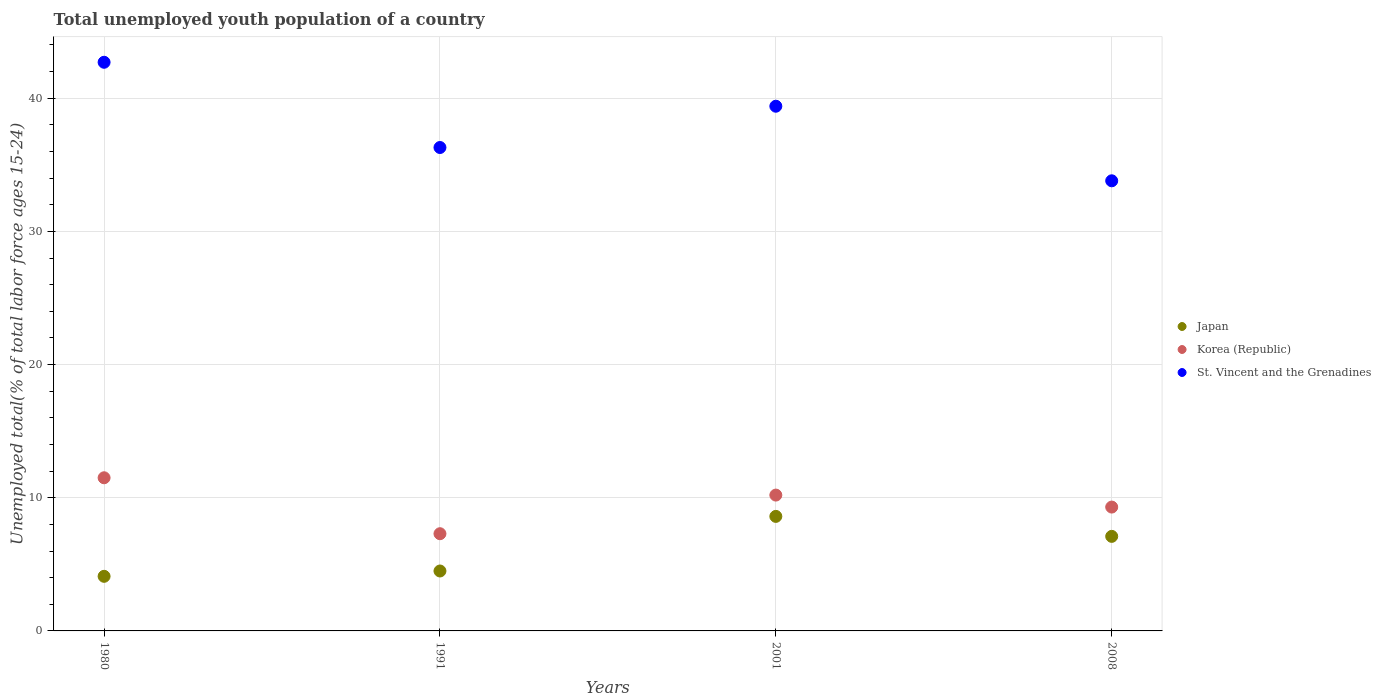Is the number of dotlines equal to the number of legend labels?
Provide a succinct answer. Yes. What is the percentage of total unemployed youth population of a country in Japan in 1980?
Make the answer very short. 4.1. Across all years, what is the maximum percentage of total unemployed youth population of a country in Japan?
Offer a very short reply. 8.6. Across all years, what is the minimum percentage of total unemployed youth population of a country in St. Vincent and the Grenadines?
Keep it short and to the point. 33.8. What is the total percentage of total unemployed youth population of a country in St. Vincent and the Grenadines in the graph?
Your answer should be very brief. 152.2. What is the difference between the percentage of total unemployed youth population of a country in Japan in 1980 and that in 2001?
Ensure brevity in your answer.  -4.5. What is the difference between the percentage of total unemployed youth population of a country in Korea (Republic) in 1991 and the percentage of total unemployed youth population of a country in Japan in 2008?
Make the answer very short. 0.2. What is the average percentage of total unemployed youth population of a country in Japan per year?
Make the answer very short. 6.08. In the year 2001, what is the difference between the percentage of total unemployed youth population of a country in Korea (Republic) and percentage of total unemployed youth population of a country in Japan?
Give a very brief answer. 1.6. In how many years, is the percentage of total unemployed youth population of a country in Japan greater than 20 %?
Your answer should be compact. 0. What is the ratio of the percentage of total unemployed youth population of a country in Korea (Republic) in 2001 to that in 2008?
Make the answer very short. 1.1. Is the percentage of total unemployed youth population of a country in St. Vincent and the Grenadines in 1980 less than that in 1991?
Make the answer very short. No. Is the difference between the percentage of total unemployed youth population of a country in Korea (Republic) in 1980 and 2001 greater than the difference between the percentage of total unemployed youth population of a country in Japan in 1980 and 2001?
Provide a short and direct response. Yes. What is the difference between the highest and the second highest percentage of total unemployed youth population of a country in Japan?
Your response must be concise. 1.5. What is the difference between the highest and the lowest percentage of total unemployed youth population of a country in Korea (Republic)?
Keep it short and to the point. 4.2. In how many years, is the percentage of total unemployed youth population of a country in St. Vincent and the Grenadines greater than the average percentage of total unemployed youth population of a country in St. Vincent and the Grenadines taken over all years?
Offer a terse response. 2. Is it the case that in every year, the sum of the percentage of total unemployed youth population of a country in Korea (Republic) and percentage of total unemployed youth population of a country in Japan  is greater than the percentage of total unemployed youth population of a country in St. Vincent and the Grenadines?
Give a very brief answer. No. Is the percentage of total unemployed youth population of a country in Korea (Republic) strictly greater than the percentage of total unemployed youth population of a country in Japan over the years?
Make the answer very short. Yes. Is the percentage of total unemployed youth population of a country in Korea (Republic) strictly less than the percentage of total unemployed youth population of a country in Japan over the years?
Your response must be concise. No. Are the values on the major ticks of Y-axis written in scientific E-notation?
Ensure brevity in your answer.  No. Where does the legend appear in the graph?
Your answer should be very brief. Center right. What is the title of the graph?
Your answer should be very brief. Total unemployed youth population of a country. Does "Botswana" appear as one of the legend labels in the graph?
Your answer should be very brief. No. What is the label or title of the Y-axis?
Your answer should be very brief. Unemployed total(% of total labor force ages 15-24). What is the Unemployed total(% of total labor force ages 15-24) of Japan in 1980?
Keep it short and to the point. 4.1. What is the Unemployed total(% of total labor force ages 15-24) of Korea (Republic) in 1980?
Your answer should be compact. 11.5. What is the Unemployed total(% of total labor force ages 15-24) of St. Vincent and the Grenadines in 1980?
Your answer should be very brief. 42.7. What is the Unemployed total(% of total labor force ages 15-24) of Korea (Republic) in 1991?
Give a very brief answer. 7.3. What is the Unemployed total(% of total labor force ages 15-24) of St. Vincent and the Grenadines in 1991?
Make the answer very short. 36.3. What is the Unemployed total(% of total labor force ages 15-24) in Japan in 2001?
Your response must be concise. 8.6. What is the Unemployed total(% of total labor force ages 15-24) of Korea (Republic) in 2001?
Ensure brevity in your answer.  10.2. What is the Unemployed total(% of total labor force ages 15-24) of St. Vincent and the Grenadines in 2001?
Your response must be concise. 39.4. What is the Unemployed total(% of total labor force ages 15-24) of Japan in 2008?
Your response must be concise. 7.1. What is the Unemployed total(% of total labor force ages 15-24) in Korea (Republic) in 2008?
Provide a succinct answer. 9.3. What is the Unemployed total(% of total labor force ages 15-24) in St. Vincent and the Grenadines in 2008?
Ensure brevity in your answer.  33.8. Across all years, what is the maximum Unemployed total(% of total labor force ages 15-24) in Japan?
Offer a terse response. 8.6. Across all years, what is the maximum Unemployed total(% of total labor force ages 15-24) in St. Vincent and the Grenadines?
Provide a short and direct response. 42.7. Across all years, what is the minimum Unemployed total(% of total labor force ages 15-24) of Japan?
Keep it short and to the point. 4.1. Across all years, what is the minimum Unemployed total(% of total labor force ages 15-24) of Korea (Republic)?
Ensure brevity in your answer.  7.3. Across all years, what is the minimum Unemployed total(% of total labor force ages 15-24) of St. Vincent and the Grenadines?
Offer a terse response. 33.8. What is the total Unemployed total(% of total labor force ages 15-24) of Japan in the graph?
Your response must be concise. 24.3. What is the total Unemployed total(% of total labor force ages 15-24) of Korea (Republic) in the graph?
Offer a terse response. 38.3. What is the total Unemployed total(% of total labor force ages 15-24) of St. Vincent and the Grenadines in the graph?
Your answer should be very brief. 152.2. What is the difference between the Unemployed total(% of total labor force ages 15-24) of Korea (Republic) in 1980 and that in 1991?
Give a very brief answer. 4.2. What is the difference between the Unemployed total(% of total labor force ages 15-24) of St. Vincent and the Grenadines in 1980 and that in 2001?
Provide a succinct answer. 3.3. What is the difference between the Unemployed total(% of total labor force ages 15-24) in St. Vincent and the Grenadines in 1980 and that in 2008?
Your response must be concise. 8.9. What is the difference between the Unemployed total(% of total labor force ages 15-24) of St. Vincent and the Grenadines in 1991 and that in 2008?
Make the answer very short. 2.5. What is the difference between the Unemployed total(% of total labor force ages 15-24) in Japan in 2001 and that in 2008?
Your response must be concise. 1.5. What is the difference between the Unemployed total(% of total labor force ages 15-24) of Japan in 1980 and the Unemployed total(% of total labor force ages 15-24) of St. Vincent and the Grenadines in 1991?
Your answer should be compact. -32.2. What is the difference between the Unemployed total(% of total labor force ages 15-24) of Korea (Republic) in 1980 and the Unemployed total(% of total labor force ages 15-24) of St. Vincent and the Grenadines in 1991?
Ensure brevity in your answer.  -24.8. What is the difference between the Unemployed total(% of total labor force ages 15-24) of Japan in 1980 and the Unemployed total(% of total labor force ages 15-24) of St. Vincent and the Grenadines in 2001?
Keep it short and to the point. -35.3. What is the difference between the Unemployed total(% of total labor force ages 15-24) of Korea (Republic) in 1980 and the Unemployed total(% of total labor force ages 15-24) of St. Vincent and the Grenadines in 2001?
Your answer should be compact. -27.9. What is the difference between the Unemployed total(% of total labor force ages 15-24) in Japan in 1980 and the Unemployed total(% of total labor force ages 15-24) in St. Vincent and the Grenadines in 2008?
Provide a succinct answer. -29.7. What is the difference between the Unemployed total(% of total labor force ages 15-24) of Korea (Republic) in 1980 and the Unemployed total(% of total labor force ages 15-24) of St. Vincent and the Grenadines in 2008?
Offer a terse response. -22.3. What is the difference between the Unemployed total(% of total labor force ages 15-24) of Japan in 1991 and the Unemployed total(% of total labor force ages 15-24) of Korea (Republic) in 2001?
Keep it short and to the point. -5.7. What is the difference between the Unemployed total(% of total labor force ages 15-24) in Japan in 1991 and the Unemployed total(% of total labor force ages 15-24) in St. Vincent and the Grenadines in 2001?
Keep it short and to the point. -34.9. What is the difference between the Unemployed total(% of total labor force ages 15-24) in Korea (Republic) in 1991 and the Unemployed total(% of total labor force ages 15-24) in St. Vincent and the Grenadines in 2001?
Offer a terse response. -32.1. What is the difference between the Unemployed total(% of total labor force ages 15-24) of Japan in 1991 and the Unemployed total(% of total labor force ages 15-24) of Korea (Republic) in 2008?
Provide a succinct answer. -4.8. What is the difference between the Unemployed total(% of total labor force ages 15-24) of Japan in 1991 and the Unemployed total(% of total labor force ages 15-24) of St. Vincent and the Grenadines in 2008?
Provide a succinct answer. -29.3. What is the difference between the Unemployed total(% of total labor force ages 15-24) of Korea (Republic) in 1991 and the Unemployed total(% of total labor force ages 15-24) of St. Vincent and the Grenadines in 2008?
Provide a short and direct response. -26.5. What is the difference between the Unemployed total(% of total labor force ages 15-24) of Japan in 2001 and the Unemployed total(% of total labor force ages 15-24) of St. Vincent and the Grenadines in 2008?
Ensure brevity in your answer.  -25.2. What is the difference between the Unemployed total(% of total labor force ages 15-24) of Korea (Republic) in 2001 and the Unemployed total(% of total labor force ages 15-24) of St. Vincent and the Grenadines in 2008?
Make the answer very short. -23.6. What is the average Unemployed total(% of total labor force ages 15-24) in Japan per year?
Provide a short and direct response. 6.08. What is the average Unemployed total(% of total labor force ages 15-24) in Korea (Republic) per year?
Your answer should be compact. 9.57. What is the average Unemployed total(% of total labor force ages 15-24) of St. Vincent and the Grenadines per year?
Your response must be concise. 38.05. In the year 1980, what is the difference between the Unemployed total(% of total labor force ages 15-24) of Japan and Unemployed total(% of total labor force ages 15-24) of St. Vincent and the Grenadines?
Make the answer very short. -38.6. In the year 1980, what is the difference between the Unemployed total(% of total labor force ages 15-24) of Korea (Republic) and Unemployed total(% of total labor force ages 15-24) of St. Vincent and the Grenadines?
Make the answer very short. -31.2. In the year 1991, what is the difference between the Unemployed total(% of total labor force ages 15-24) in Japan and Unemployed total(% of total labor force ages 15-24) in Korea (Republic)?
Provide a succinct answer. -2.8. In the year 1991, what is the difference between the Unemployed total(% of total labor force ages 15-24) of Japan and Unemployed total(% of total labor force ages 15-24) of St. Vincent and the Grenadines?
Give a very brief answer. -31.8. In the year 1991, what is the difference between the Unemployed total(% of total labor force ages 15-24) of Korea (Republic) and Unemployed total(% of total labor force ages 15-24) of St. Vincent and the Grenadines?
Keep it short and to the point. -29. In the year 2001, what is the difference between the Unemployed total(% of total labor force ages 15-24) of Japan and Unemployed total(% of total labor force ages 15-24) of St. Vincent and the Grenadines?
Provide a succinct answer. -30.8. In the year 2001, what is the difference between the Unemployed total(% of total labor force ages 15-24) of Korea (Republic) and Unemployed total(% of total labor force ages 15-24) of St. Vincent and the Grenadines?
Provide a succinct answer. -29.2. In the year 2008, what is the difference between the Unemployed total(% of total labor force ages 15-24) in Japan and Unemployed total(% of total labor force ages 15-24) in Korea (Republic)?
Your response must be concise. -2.2. In the year 2008, what is the difference between the Unemployed total(% of total labor force ages 15-24) of Japan and Unemployed total(% of total labor force ages 15-24) of St. Vincent and the Grenadines?
Give a very brief answer. -26.7. In the year 2008, what is the difference between the Unemployed total(% of total labor force ages 15-24) in Korea (Republic) and Unemployed total(% of total labor force ages 15-24) in St. Vincent and the Grenadines?
Provide a succinct answer. -24.5. What is the ratio of the Unemployed total(% of total labor force ages 15-24) of Japan in 1980 to that in 1991?
Offer a very short reply. 0.91. What is the ratio of the Unemployed total(% of total labor force ages 15-24) in Korea (Republic) in 1980 to that in 1991?
Provide a short and direct response. 1.58. What is the ratio of the Unemployed total(% of total labor force ages 15-24) of St. Vincent and the Grenadines in 1980 to that in 1991?
Offer a very short reply. 1.18. What is the ratio of the Unemployed total(% of total labor force ages 15-24) in Japan in 1980 to that in 2001?
Make the answer very short. 0.48. What is the ratio of the Unemployed total(% of total labor force ages 15-24) in Korea (Republic) in 1980 to that in 2001?
Give a very brief answer. 1.13. What is the ratio of the Unemployed total(% of total labor force ages 15-24) of St. Vincent and the Grenadines in 1980 to that in 2001?
Your answer should be compact. 1.08. What is the ratio of the Unemployed total(% of total labor force ages 15-24) in Japan in 1980 to that in 2008?
Offer a very short reply. 0.58. What is the ratio of the Unemployed total(% of total labor force ages 15-24) of Korea (Republic) in 1980 to that in 2008?
Your answer should be very brief. 1.24. What is the ratio of the Unemployed total(% of total labor force ages 15-24) of St. Vincent and the Grenadines in 1980 to that in 2008?
Your response must be concise. 1.26. What is the ratio of the Unemployed total(% of total labor force ages 15-24) of Japan in 1991 to that in 2001?
Make the answer very short. 0.52. What is the ratio of the Unemployed total(% of total labor force ages 15-24) in Korea (Republic) in 1991 to that in 2001?
Offer a terse response. 0.72. What is the ratio of the Unemployed total(% of total labor force ages 15-24) of St. Vincent and the Grenadines in 1991 to that in 2001?
Your response must be concise. 0.92. What is the ratio of the Unemployed total(% of total labor force ages 15-24) in Japan in 1991 to that in 2008?
Provide a succinct answer. 0.63. What is the ratio of the Unemployed total(% of total labor force ages 15-24) of Korea (Republic) in 1991 to that in 2008?
Give a very brief answer. 0.78. What is the ratio of the Unemployed total(% of total labor force ages 15-24) in St. Vincent and the Grenadines in 1991 to that in 2008?
Make the answer very short. 1.07. What is the ratio of the Unemployed total(% of total labor force ages 15-24) in Japan in 2001 to that in 2008?
Provide a succinct answer. 1.21. What is the ratio of the Unemployed total(% of total labor force ages 15-24) in Korea (Republic) in 2001 to that in 2008?
Provide a short and direct response. 1.1. What is the ratio of the Unemployed total(% of total labor force ages 15-24) in St. Vincent and the Grenadines in 2001 to that in 2008?
Your response must be concise. 1.17. 